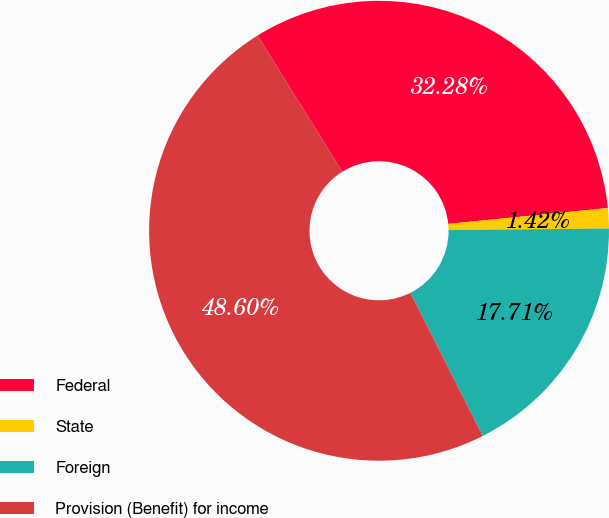Convert chart. <chart><loc_0><loc_0><loc_500><loc_500><pie_chart><fcel>Federal<fcel>State<fcel>Foreign<fcel>Provision (Benefit) for income<nl><fcel>32.28%<fcel>1.42%<fcel>17.71%<fcel>48.6%<nl></chart> 